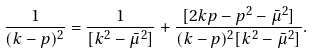<formula> <loc_0><loc_0><loc_500><loc_500>\frac { 1 } { ( k - p ) ^ { 2 } } = \frac { 1 } { [ k ^ { 2 } - \bar { \mu } ^ { 2 } ] } + \frac { [ 2 k p - p ^ { 2 } - \bar { \mu } ^ { 2 } ] } { ( k - p ) ^ { 2 } [ k ^ { 2 } - \bar { \mu } ^ { 2 } ] } .</formula> 